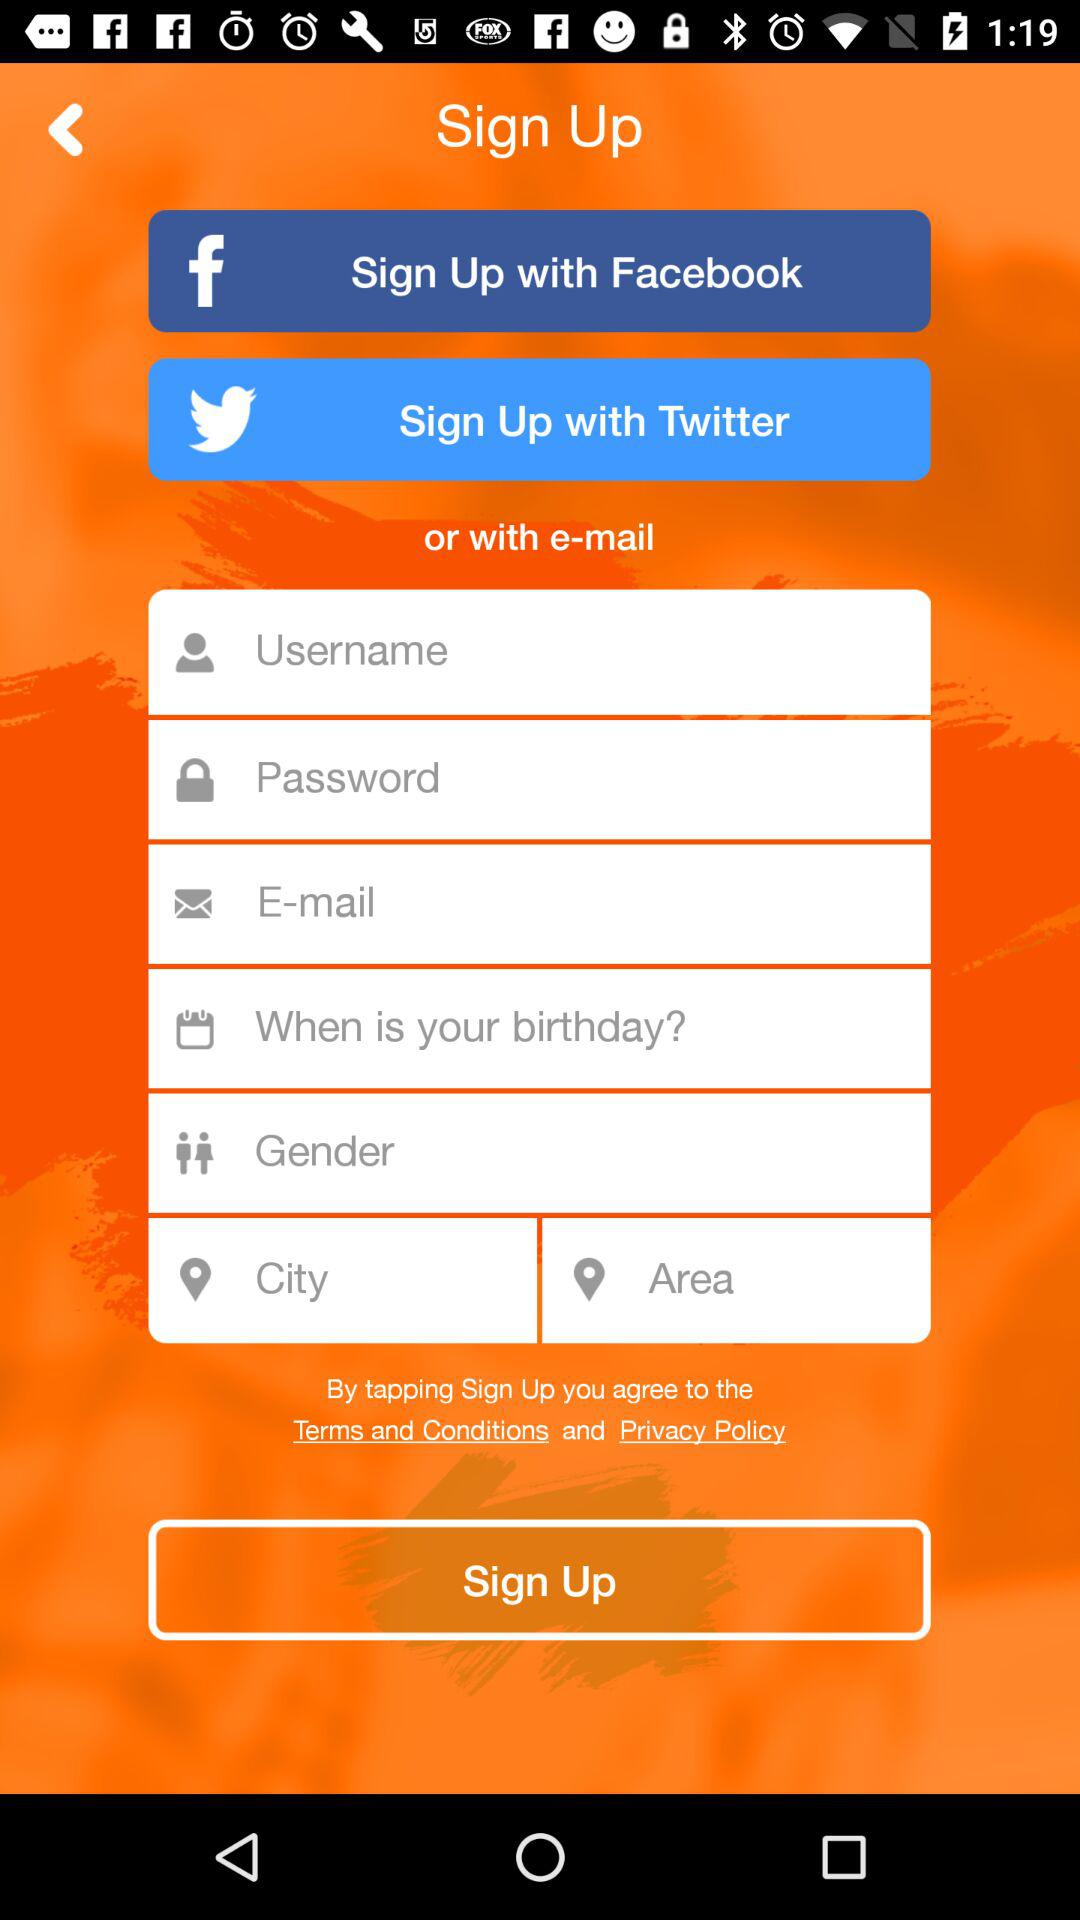What accounts can I use to sign up? You can use the accounts of "Facebook", "Twitter" and "e-mail" to sign up. 